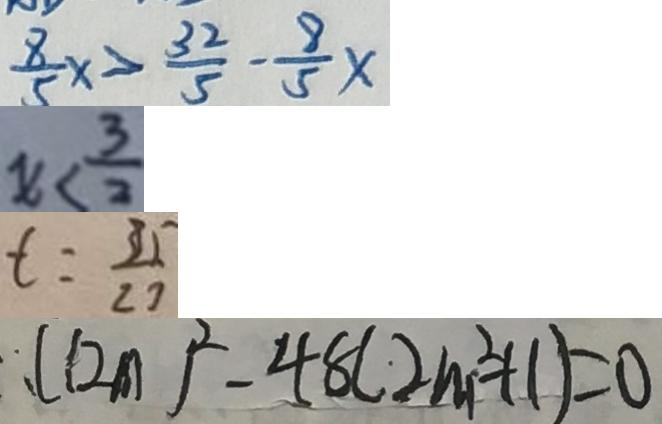Convert formula to latex. <formula><loc_0><loc_0><loc_500><loc_500>\frac { 8 } { 5 } x > \frac { 3 2 } { 5 } - \frac { 8 } { 5 } x 
 x < \frac { 3 } { 2 } 
 t = \frac { 3 5 } { 2 7 } 
 ( 1 2 m ) ^ { 2 } - 4 8 ( 2 m ^ { 2 } + 1 ) = 0</formula> 